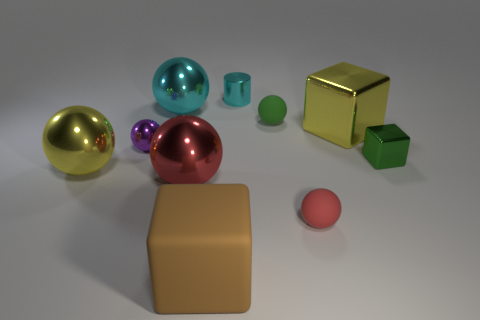Do the big rubber object and the small shiny block have the same color?
Offer a terse response. No. What number of things are either matte things that are left of the green matte thing or green metallic objects?
Your response must be concise. 2. The green object that is the same material as the tiny cyan object is what size?
Make the answer very short. Small. Is the number of green cubes that are to the left of the big red ball greater than the number of big cyan balls?
Give a very brief answer. No. There is a big red metallic object; does it have the same shape as the small object that is in front of the green cube?
Offer a terse response. Yes. How many big things are red things or yellow objects?
Keep it short and to the point. 3. The thing that is the same color as the tiny cylinder is what size?
Your answer should be compact. Large. What is the color of the tiny shiny object to the right of the big object on the right side of the brown matte block?
Offer a very short reply. Green. Is the big yellow cube made of the same material as the small object that is on the left side of the cylinder?
Your answer should be compact. Yes. What material is the big block in front of the large yellow block?
Your response must be concise. Rubber. 